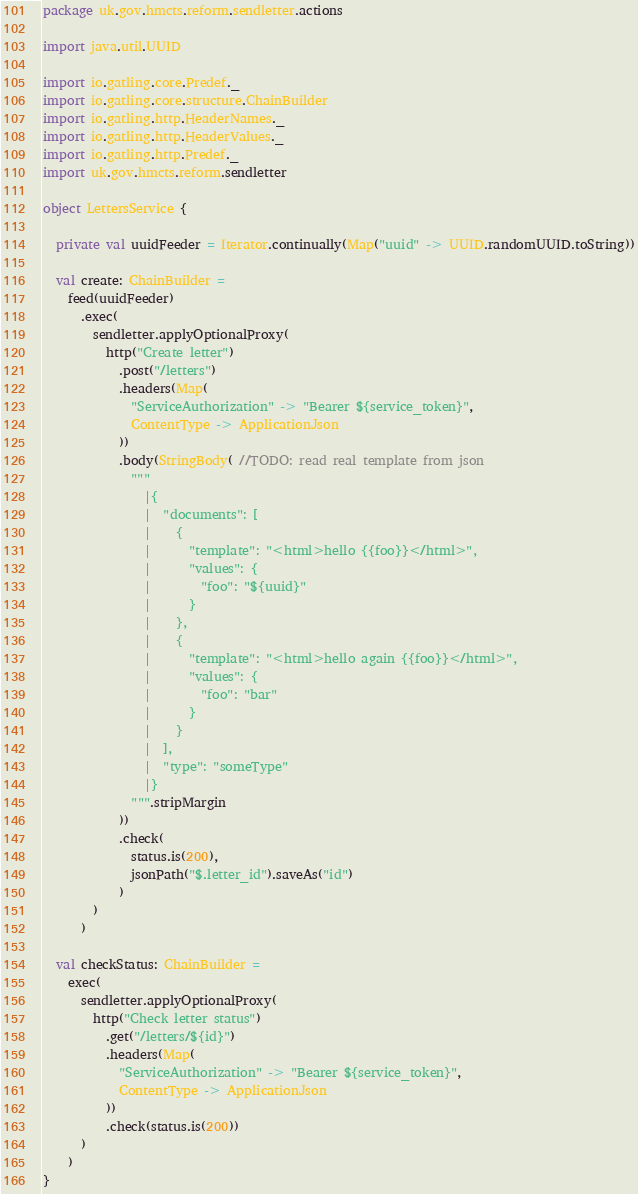Convert code to text. <code><loc_0><loc_0><loc_500><loc_500><_Scala_>package uk.gov.hmcts.reform.sendletter.actions

import java.util.UUID

import io.gatling.core.Predef._
import io.gatling.core.structure.ChainBuilder
import io.gatling.http.HeaderNames._
import io.gatling.http.HeaderValues._
import io.gatling.http.Predef._
import uk.gov.hmcts.reform.sendletter

object LettersService {

  private val uuidFeeder = Iterator.continually(Map("uuid" -> UUID.randomUUID.toString))

  val create: ChainBuilder =
    feed(uuidFeeder)
      .exec(
        sendletter.applyOptionalProxy(
          http("Create letter")
            .post("/letters")
            .headers(Map(
              "ServiceAuthorization" -> "Bearer ${service_token}",
              ContentType -> ApplicationJson
            ))
            .body(StringBody( //TODO: read real template from json
              """
                |{
                |  "documents": [
                |    {
                |      "template": "<html>hello {{foo}}</html>",
                |      "values": {
                |        "foo": "${uuid}"
                |      }
                |    },
                |    {
                |      "template": "<html>hello again {{foo}}</html>",
                |      "values": {
                |        "foo": "bar"
                |      }
                |    }
                |  ],
                |  "type": "someType"
                |}
              """.stripMargin
            ))
            .check(
              status.is(200),
              jsonPath("$.letter_id").saveAs("id")
            )
        )
      )

  val checkStatus: ChainBuilder =
    exec(
      sendletter.applyOptionalProxy(
        http("Check letter status")
          .get("/letters/${id}")
          .headers(Map(
            "ServiceAuthorization" -> "Bearer ${service_token}",
            ContentType -> ApplicationJson
          ))
          .check(status.is(200))
      )
    )
}
</code> 